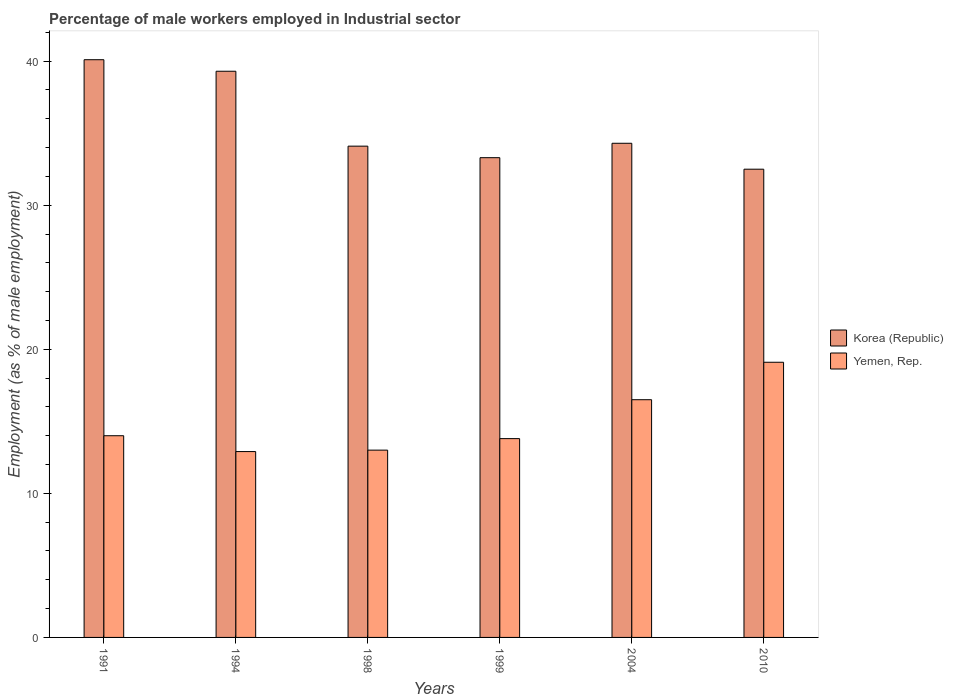How many different coloured bars are there?
Your response must be concise. 2. Are the number of bars per tick equal to the number of legend labels?
Give a very brief answer. Yes. Are the number of bars on each tick of the X-axis equal?
Offer a terse response. Yes. What is the label of the 4th group of bars from the left?
Your answer should be very brief. 1999. In how many cases, is the number of bars for a given year not equal to the number of legend labels?
Your answer should be compact. 0. What is the percentage of male workers employed in Industrial sector in Yemen, Rep. in 1991?
Your answer should be compact. 14. Across all years, what is the maximum percentage of male workers employed in Industrial sector in Korea (Republic)?
Provide a short and direct response. 40.1. Across all years, what is the minimum percentage of male workers employed in Industrial sector in Korea (Republic)?
Ensure brevity in your answer.  32.5. In which year was the percentage of male workers employed in Industrial sector in Yemen, Rep. maximum?
Provide a succinct answer. 2010. What is the total percentage of male workers employed in Industrial sector in Korea (Republic) in the graph?
Your answer should be very brief. 213.6. What is the difference between the percentage of male workers employed in Industrial sector in Korea (Republic) in 1991 and that in 2004?
Your answer should be very brief. 5.8. What is the difference between the percentage of male workers employed in Industrial sector in Yemen, Rep. in 2010 and the percentage of male workers employed in Industrial sector in Korea (Republic) in 1999?
Offer a very short reply. -14.2. What is the average percentage of male workers employed in Industrial sector in Korea (Republic) per year?
Keep it short and to the point. 35.6. In the year 2010, what is the difference between the percentage of male workers employed in Industrial sector in Yemen, Rep. and percentage of male workers employed in Industrial sector in Korea (Republic)?
Your response must be concise. -13.4. In how many years, is the percentage of male workers employed in Industrial sector in Yemen, Rep. greater than 18 %?
Your answer should be very brief. 1. What is the ratio of the percentage of male workers employed in Industrial sector in Yemen, Rep. in 1991 to that in 1998?
Offer a terse response. 1.08. Is the percentage of male workers employed in Industrial sector in Yemen, Rep. in 1994 less than that in 1998?
Keep it short and to the point. Yes. Is the difference between the percentage of male workers employed in Industrial sector in Yemen, Rep. in 2004 and 2010 greater than the difference between the percentage of male workers employed in Industrial sector in Korea (Republic) in 2004 and 2010?
Provide a short and direct response. No. What is the difference between the highest and the second highest percentage of male workers employed in Industrial sector in Yemen, Rep.?
Provide a succinct answer. 2.6. What is the difference between the highest and the lowest percentage of male workers employed in Industrial sector in Yemen, Rep.?
Provide a succinct answer. 6.2. In how many years, is the percentage of male workers employed in Industrial sector in Yemen, Rep. greater than the average percentage of male workers employed in Industrial sector in Yemen, Rep. taken over all years?
Ensure brevity in your answer.  2. Is the sum of the percentage of male workers employed in Industrial sector in Yemen, Rep. in 1994 and 1999 greater than the maximum percentage of male workers employed in Industrial sector in Korea (Republic) across all years?
Give a very brief answer. No. What does the 2nd bar from the left in 1994 represents?
Keep it short and to the point. Yemen, Rep. How many years are there in the graph?
Your answer should be very brief. 6. What is the difference between two consecutive major ticks on the Y-axis?
Your answer should be very brief. 10. How many legend labels are there?
Your response must be concise. 2. What is the title of the graph?
Offer a terse response. Percentage of male workers employed in Industrial sector. What is the label or title of the X-axis?
Offer a terse response. Years. What is the label or title of the Y-axis?
Your response must be concise. Employment (as % of male employment). What is the Employment (as % of male employment) in Korea (Republic) in 1991?
Provide a succinct answer. 40.1. What is the Employment (as % of male employment) of Korea (Republic) in 1994?
Offer a terse response. 39.3. What is the Employment (as % of male employment) of Yemen, Rep. in 1994?
Provide a succinct answer. 12.9. What is the Employment (as % of male employment) of Korea (Republic) in 1998?
Your answer should be compact. 34.1. What is the Employment (as % of male employment) of Korea (Republic) in 1999?
Your response must be concise. 33.3. What is the Employment (as % of male employment) in Yemen, Rep. in 1999?
Provide a short and direct response. 13.8. What is the Employment (as % of male employment) of Korea (Republic) in 2004?
Your response must be concise. 34.3. What is the Employment (as % of male employment) in Yemen, Rep. in 2004?
Give a very brief answer. 16.5. What is the Employment (as % of male employment) of Korea (Republic) in 2010?
Make the answer very short. 32.5. What is the Employment (as % of male employment) in Yemen, Rep. in 2010?
Your response must be concise. 19.1. Across all years, what is the maximum Employment (as % of male employment) of Korea (Republic)?
Give a very brief answer. 40.1. Across all years, what is the maximum Employment (as % of male employment) in Yemen, Rep.?
Your response must be concise. 19.1. Across all years, what is the minimum Employment (as % of male employment) in Korea (Republic)?
Give a very brief answer. 32.5. Across all years, what is the minimum Employment (as % of male employment) in Yemen, Rep.?
Give a very brief answer. 12.9. What is the total Employment (as % of male employment) in Korea (Republic) in the graph?
Make the answer very short. 213.6. What is the total Employment (as % of male employment) in Yemen, Rep. in the graph?
Give a very brief answer. 89.3. What is the difference between the Employment (as % of male employment) in Korea (Republic) in 1991 and that in 1994?
Keep it short and to the point. 0.8. What is the difference between the Employment (as % of male employment) in Korea (Republic) in 1991 and that in 1999?
Provide a short and direct response. 6.8. What is the difference between the Employment (as % of male employment) in Yemen, Rep. in 1991 and that in 1999?
Provide a succinct answer. 0.2. What is the difference between the Employment (as % of male employment) of Korea (Republic) in 1991 and that in 2004?
Provide a short and direct response. 5.8. What is the difference between the Employment (as % of male employment) of Korea (Republic) in 1991 and that in 2010?
Ensure brevity in your answer.  7.6. What is the difference between the Employment (as % of male employment) of Yemen, Rep. in 1991 and that in 2010?
Give a very brief answer. -5.1. What is the difference between the Employment (as % of male employment) in Korea (Republic) in 1994 and that in 1999?
Keep it short and to the point. 6. What is the difference between the Employment (as % of male employment) in Yemen, Rep. in 1994 and that in 1999?
Keep it short and to the point. -0.9. What is the difference between the Employment (as % of male employment) of Korea (Republic) in 1994 and that in 2004?
Offer a very short reply. 5. What is the difference between the Employment (as % of male employment) in Yemen, Rep. in 1994 and that in 2010?
Ensure brevity in your answer.  -6.2. What is the difference between the Employment (as % of male employment) in Korea (Republic) in 1998 and that in 1999?
Provide a short and direct response. 0.8. What is the difference between the Employment (as % of male employment) of Yemen, Rep. in 1998 and that in 1999?
Your answer should be very brief. -0.8. What is the difference between the Employment (as % of male employment) of Korea (Republic) in 1998 and that in 2004?
Your answer should be very brief. -0.2. What is the difference between the Employment (as % of male employment) of Yemen, Rep. in 1998 and that in 2004?
Keep it short and to the point. -3.5. What is the difference between the Employment (as % of male employment) in Yemen, Rep. in 1999 and that in 2004?
Offer a very short reply. -2.7. What is the difference between the Employment (as % of male employment) in Yemen, Rep. in 1999 and that in 2010?
Provide a succinct answer. -5.3. What is the difference between the Employment (as % of male employment) of Korea (Republic) in 2004 and that in 2010?
Offer a terse response. 1.8. What is the difference between the Employment (as % of male employment) of Yemen, Rep. in 2004 and that in 2010?
Your response must be concise. -2.6. What is the difference between the Employment (as % of male employment) in Korea (Republic) in 1991 and the Employment (as % of male employment) in Yemen, Rep. in 1994?
Offer a terse response. 27.2. What is the difference between the Employment (as % of male employment) in Korea (Republic) in 1991 and the Employment (as % of male employment) in Yemen, Rep. in 1998?
Offer a very short reply. 27.1. What is the difference between the Employment (as % of male employment) in Korea (Republic) in 1991 and the Employment (as % of male employment) in Yemen, Rep. in 1999?
Your answer should be very brief. 26.3. What is the difference between the Employment (as % of male employment) in Korea (Republic) in 1991 and the Employment (as % of male employment) in Yemen, Rep. in 2004?
Your answer should be very brief. 23.6. What is the difference between the Employment (as % of male employment) in Korea (Republic) in 1994 and the Employment (as % of male employment) in Yemen, Rep. in 1998?
Your answer should be compact. 26.3. What is the difference between the Employment (as % of male employment) of Korea (Republic) in 1994 and the Employment (as % of male employment) of Yemen, Rep. in 1999?
Offer a very short reply. 25.5. What is the difference between the Employment (as % of male employment) of Korea (Republic) in 1994 and the Employment (as % of male employment) of Yemen, Rep. in 2004?
Keep it short and to the point. 22.8. What is the difference between the Employment (as % of male employment) in Korea (Republic) in 1994 and the Employment (as % of male employment) in Yemen, Rep. in 2010?
Offer a very short reply. 20.2. What is the difference between the Employment (as % of male employment) in Korea (Republic) in 1998 and the Employment (as % of male employment) in Yemen, Rep. in 1999?
Make the answer very short. 20.3. What is the difference between the Employment (as % of male employment) in Korea (Republic) in 1999 and the Employment (as % of male employment) in Yemen, Rep. in 2010?
Provide a succinct answer. 14.2. What is the difference between the Employment (as % of male employment) of Korea (Republic) in 2004 and the Employment (as % of male employment) of Yemen, Rep. in 2010?
Give a very brief answer. 15.2. What is the average Employment (as % of male employment) in Korea (Republic) per year?
Provide a short and direct response. 35.6. What is the average Employment (as % of male employment) of Yemen, Rep. per year?
Provide a succinct answer. 14.88. In the year 1991, what is the difference between the Employment (as % of male employment) of Korea (Republic) and Employment (as % of male employment) of Yemen, Rep.?
Give a very brief answer. 26.1. In the year 1994, what is the difference between the Employment (as % of male employment) in Korea (Republic) and Employment (as % of male employment) in Yemen, Rep.?
Your response must be concise. 26.4. In the year 1998, what is the difference between the Employment (as % of male employment) in Korea (Republic) and Employment (as % of male employment) in Yemen, Rep.?
Ensure brevity in your answer.  21.1. In the year 1999, what is the difference between the Employment (as % of male employment) in Korea (Republic) and Employment (as % of male employment) in Yemen, Rep.?
Give a very brief answer. 19.5. In the year 2004, what is the difference between the Employment (as % of male employment) of Korea (Republic) and Employment (as % of male employment) of Yemen, Rep.?
Offer a very short reply. 17.8. What is the ratio of the Employment (as % of male employment) in Korea (Republic) in 1991 to that in 1994?
Provide a short and direct response. 1.02. What is the ratio of the Employment (as % of male employment) in Yemen, Rep. in 1991 to that in 1994?
Your answer should be compact. 1.09. What is the ratio of the Employment (as % of male employment) of Korea (Republic) in 1991 to that in 1998?
Your answer should be compact. 1.18. What is the ratio of the Employment (as % of male employment) of Korea (Republic) in 1991 to that in 1999?
Offer a very short reply. 1.2. What is the ratio of the Employment (as % of male employment) in Yemen, Rep. in 1991 to that in 1999?
Make the answer very short. 1.01. What is the ratio of the Employment (as % of male employment) of Korea (Republic) in 1991 to that in 2004?
Your answer should be compact. 1.17. What is the ratio of the Employment (as % of male employment) in Yemen, Rep. in 1991 to that in 2004?
Give a very brief answer. 0.85. What is the ratio of the Employment (as % of male employment) of Korea (Republic) in 1991 to that in 2010?
Offer a terse response. 1.23. What is the ratio of the Employment (as % of male employment) in Yemen, Rep. in 1991 to that in 2010?
Offer a terse response. 0.73. What is the ratio of the Employment (as % of male employment) in Korea (Republic) in 1994 to that in 1998?
Provide a succinct answer. 1.15. What is the ratio of the Employment (as % of male employment) of Yemen, Rep. in 1994 to that in 1998?
Provide a short and direct response. 0.99. What is the ratio of the Employment (as % of male employment) in Korea (Republic) in 1994 to that in 1999?
Your response must be concise. 1.18. What is the ratio of the Employment (as % of male employment) of Yemen, Rep. in 1994 to that in 1999?
Offer a terse response. 0.93. What is the ratio of the Employment (as % of male employment) in Korea (Republic) in 1994 to that in 2004?
Provide a succinct answer. 1.15. What is the ratio of the Employment (as % of male employment) in Yemen, Rep. in 1994 to that in 2004?
Provide a succinct answer. 0.78. What is the ratio of the Employment (as % of male employment) of Korea (Republic) in 1994 to that in 2010?
Make the answer very short. 1.21. What is the ratio of the Employment (as % of male employment) of Yemen, Rep. in 1994 to that in 2010?
Offer a terse response. 0.68. What is the ratio of the Employment (as % of male employment) in Korea (Republic) in 1998 to that in 1999?
Your answer should be very brief. 1.02. What is the ratio of the Employment (as % of male employment) of Yemen, Rep. in 1998 to that in 1999?
Ensure brevity in your answer.  0.94. What is the ratio of the Employment (as % of male employment) of Yemen, Rep. in 1998 to that in 2004?
Give a very brief answer. 0.79. What is the ratio of the Employment (as % of male employment) of Korea (Republic) in 1998 to that in 2010?
Provide a succinct answer. 1.05. What is the ratio of the Employment (as % of male employment) of Yemen, Rep. in 1998 to that in 2010?
Your answer should be compact. 0.68. What is the ratio of the Employment (as % of male employment) of Korea (Republic) in 1999 to that in 2004?
Provide a succinct answer. 0.97. What is the ratio of the Employment (as % of male employment) in Yemen, Rep. in 1999 to that in 2004?
Provide a succinct answer. 0.84. What is the ratio of the Employment (as % of male employment) of Korea (Republic) in 1999 to that in 2010?
Offer a terse response. 1.02. What is the ratio of the Employment (as % of male employment) of Yemen, Rep. in 1999 to that in 2010?
Offer a terse response. 0.72. What is the ratio of the Employment (as % of male employment) of Korea (Republic) in 2004 to that in 2010?
Your answer should be very brief. 1.06. What is the ratio of the Employment (as % of male employment) in Yemen, Rep. in 2004 to that in 2010?
Give a very brief answer. 0.86. What is the difference between the highest and the lowest Employment (as % of male employment) in Korea (Republic)?
Provide a short and direct response. 7.6. What is the difference between the highest and the lowest Employment (as % of male employment) of Yemen, Rep.?
Your answer should be compact. 6.2. 